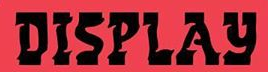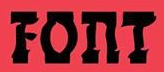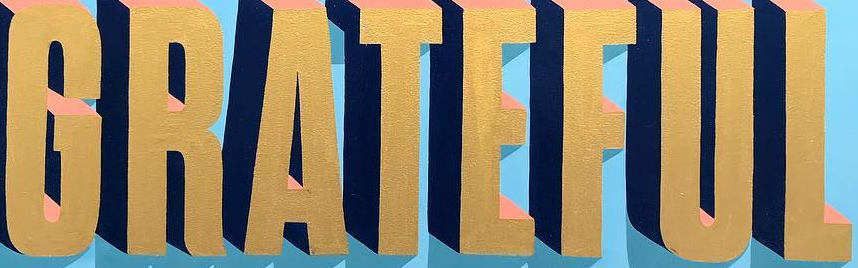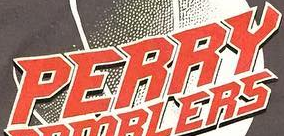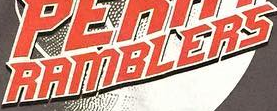What words are shown in these images in order, separated by a semicolon? DISPLAY; FOnT; GRATEFUL; PERRY; RAMBLERS 